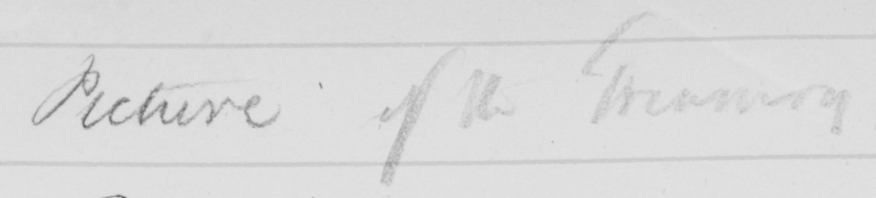Please transcribe the handwritten text in this image. Picture of the Treasury 